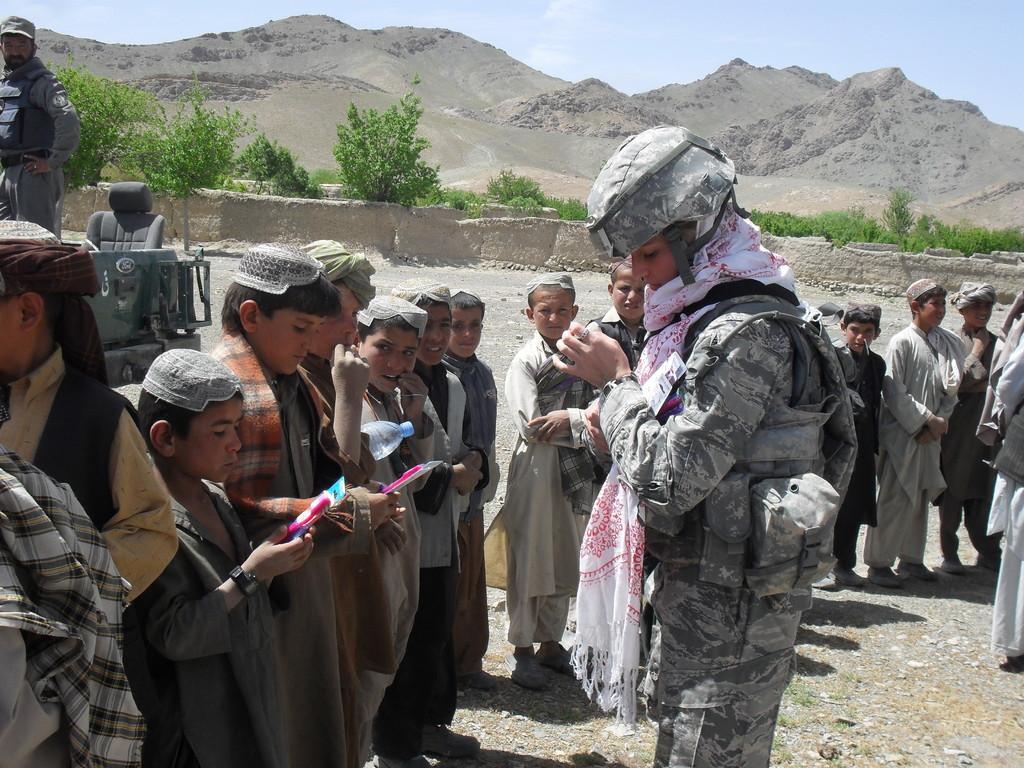Could you give a brief overview of what you see in this image? In this image I see a woman, man and number of children and I see that this woman is wearing a helmet and a scarf on her neck and I see that there is a bottle over here and I see the ground. In the background I see the vehicle, wall, trees, mountains and the sky. 